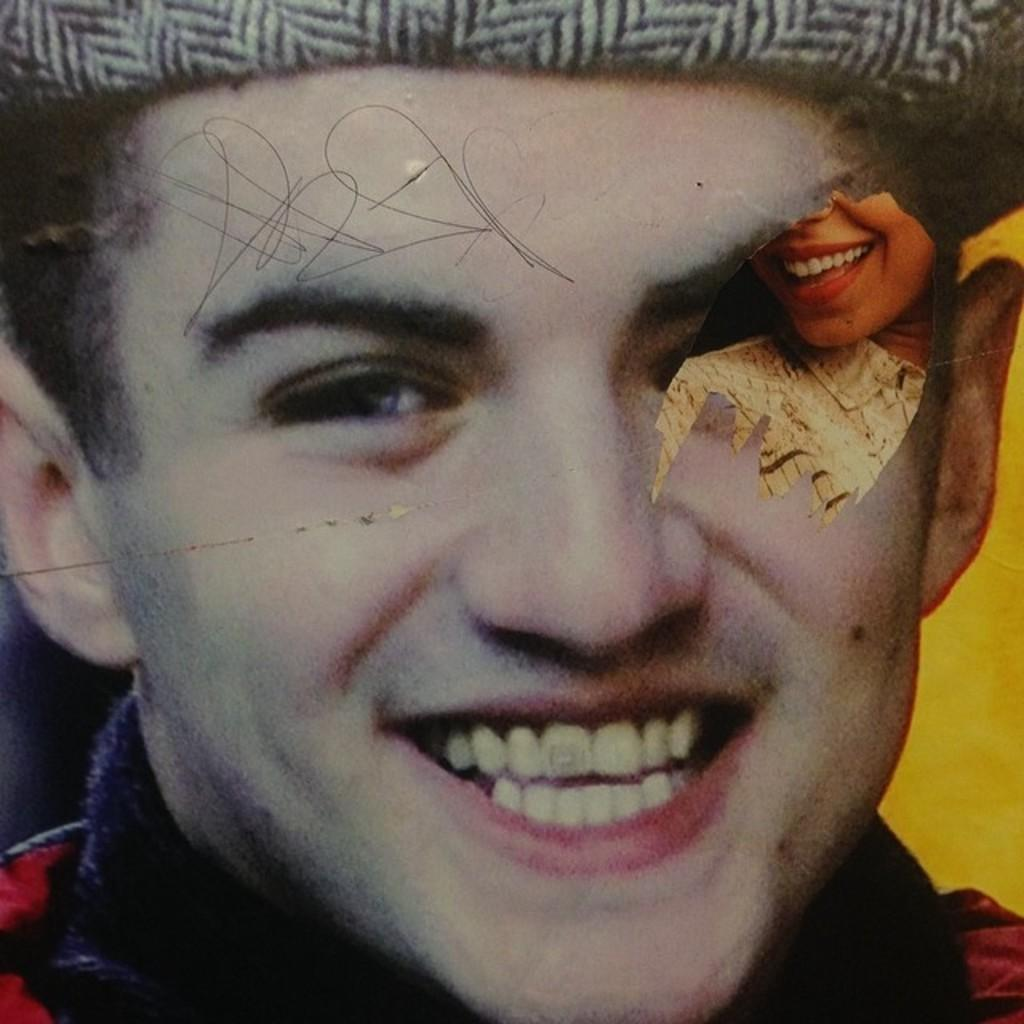What is featured on the poster in the image? The poster in the image has a man's face and a woman's face. Are there any additional features on the poster? Yes, there is scribbling on the poster. What is the taste of the sponge in the image? There is no sponge present in the image, so it is not possible to determine its taste. 